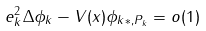<formula> <loc_0><loc_0><loc_500><loc_500>\| \ e _ { k } ^ { 2 } \Delta \phi _ { k } - V ( x ) \phi _ { k } \| _ { * , { P } _ { k } } = o ( 1 )</formula> 